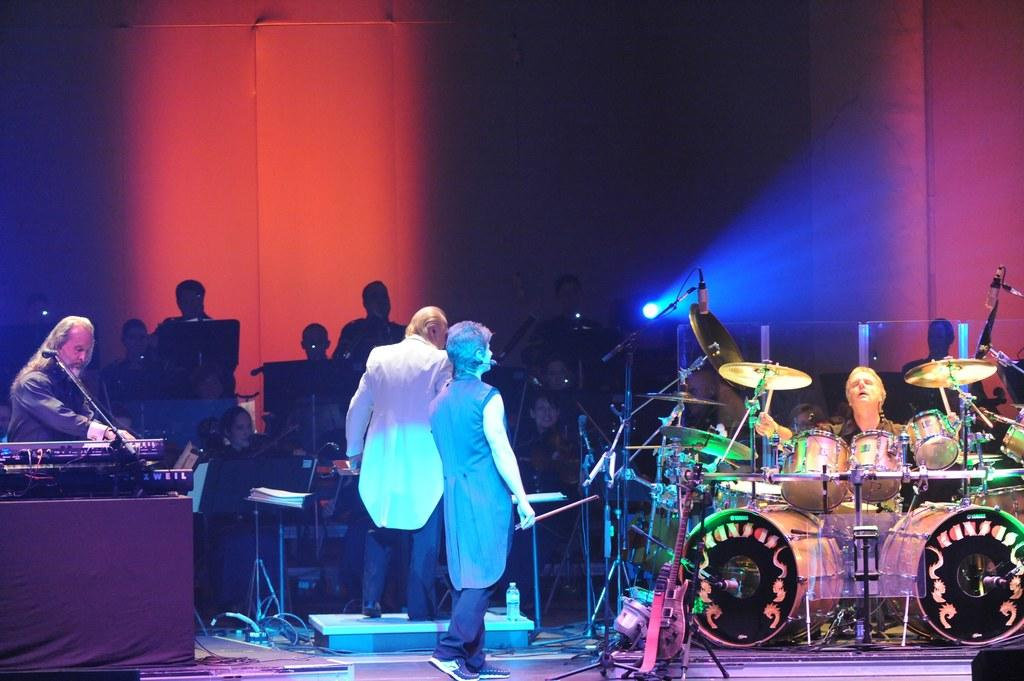What is the main subject of the image? The main subject of the image is a group of people. What are the people in the group doing? The people in the group are playing musical instruments. Can you tell me how many horses are present in the image? There are no horses present in the image; it features a group of people playing musical instruments. What type of force is being applied by the people in the image? There is no reference to any force being applied by the people in the image; they are simply playing musical instruments. 